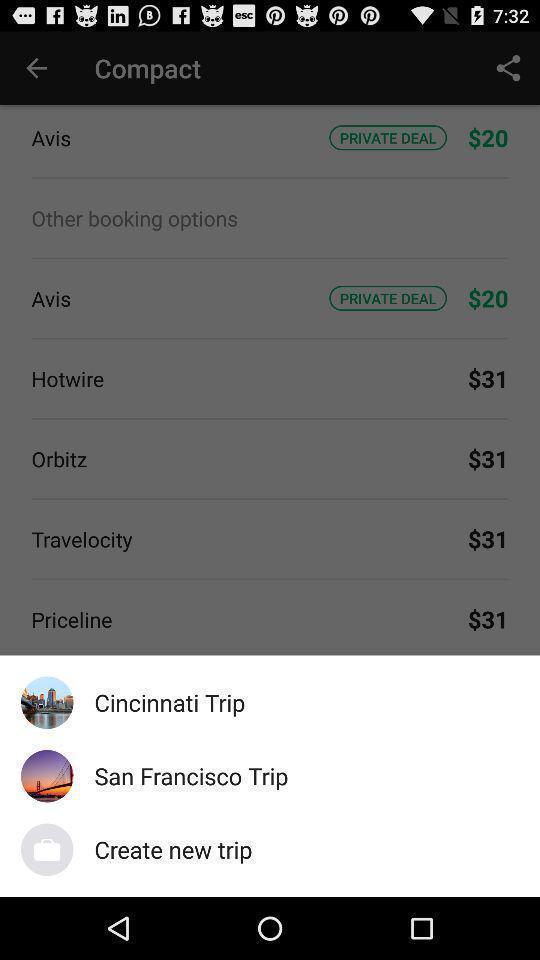Describe the visual elements of this screenshot. Pop-up shows multiple options in a travel app. 